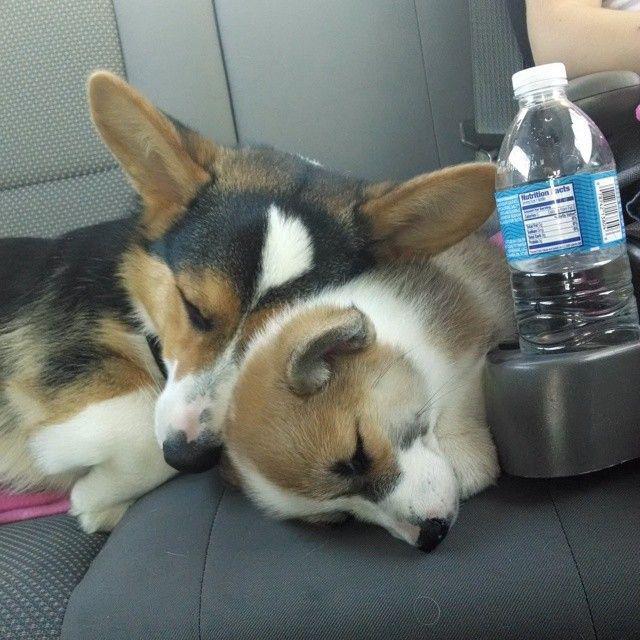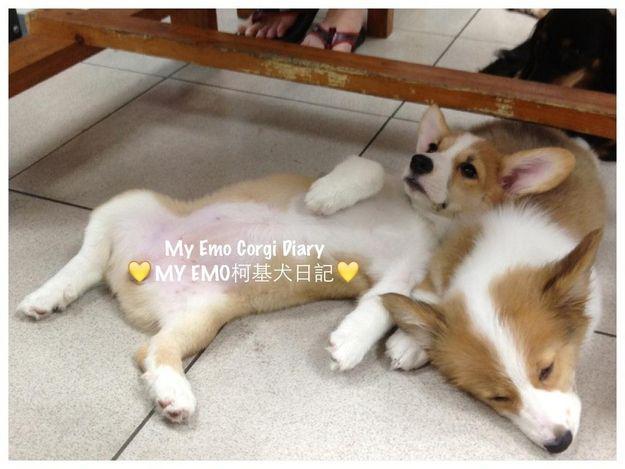The first image is the image on the left, the second image is the image on the right. Assess this claim about the two images: "One image contains one orange-and-white corgi posed on its belly with its rear toward the camera.". Correct or not? Answer yes or no. No. The first image is the image on the left, the second image is the image on the right. Evaluate the accuracy of this statement regarding the images: "There is at least four dogs in the left image.". Is it true? Answer yes or no. No. 